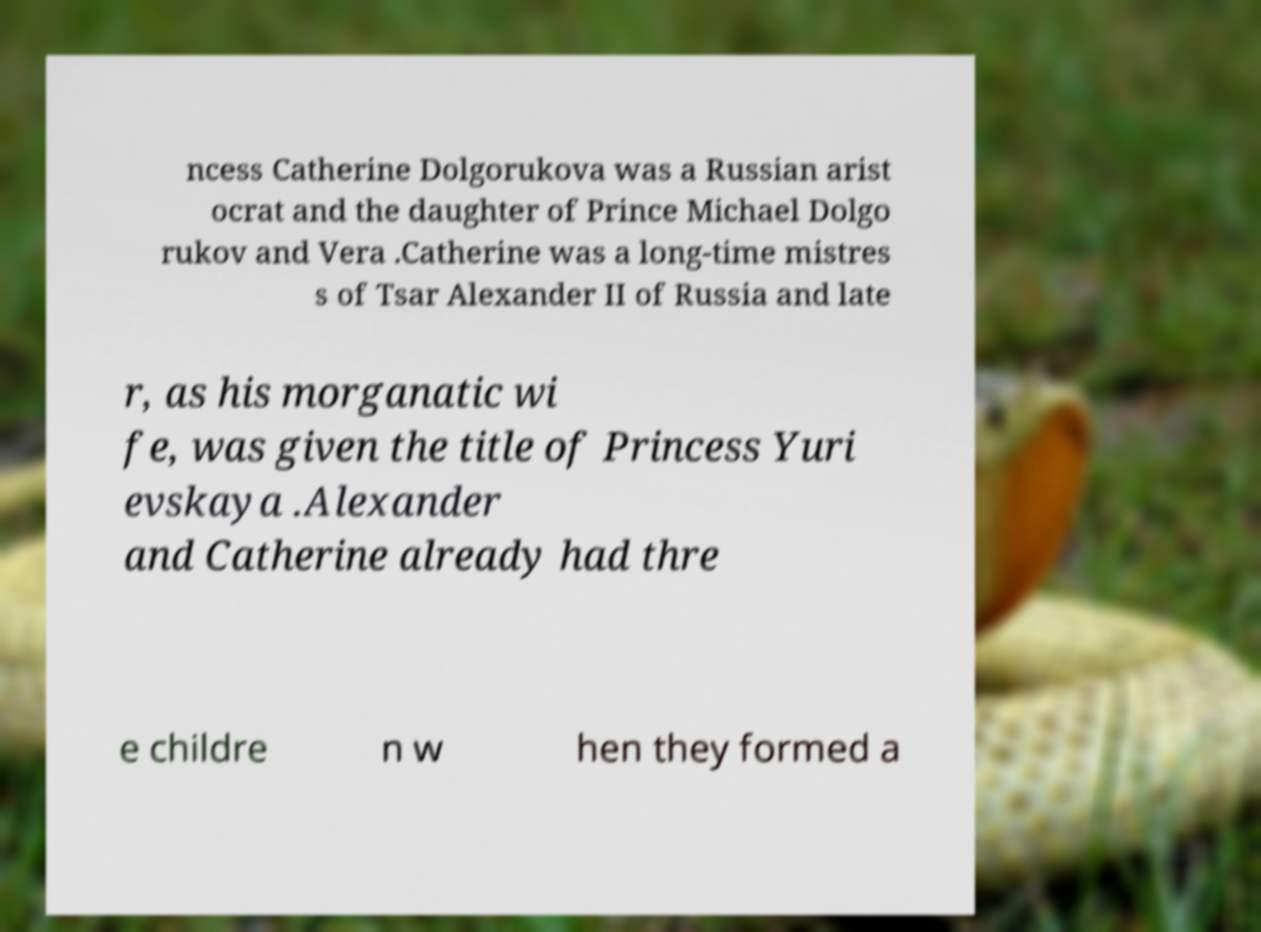There's text embedded in this image that I need extracted. Can you transcribe it verbatim? ncess Catherine Dolgorukova was a Russian arist ocrat and the daughter of Prince Michael Dolgo rukov and Vera .Catherine was a long-time mistres s of Tsar Alexander II of Russia and late r, as his morganatic wi fe, was given the title of Princess Yuri evskaya .Alexander and Catherine already had thre e childre n w hen they formed a 